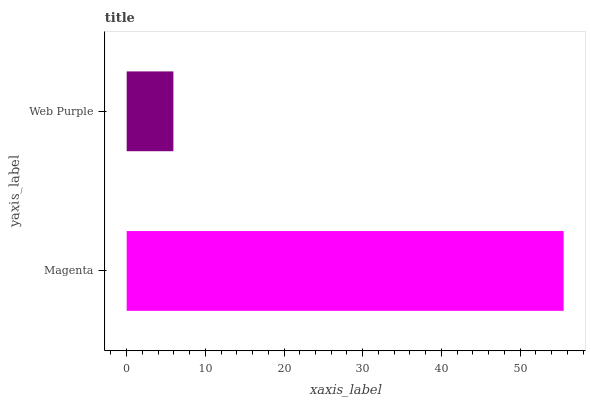Is Web Purple the minimum?
Answer yes or no. Yes. Is Magenta the maximum?
Answer yes or no. Yes. Is Web Purple the maximum?
Answer yes or no. No. Is Magenta greater than Web Purple?
Answer yes or no. Yes. Is Web Purple less than Magenta?
Answer yes or no. Yes. Is Web Purple greater than Magenta?
Answer yes or no. No. Is Magenta less than Web Purple?
Answer yes or no. No. Is Magenta the high median?
Answer yes or no. Yes. Is Web Purple the low median?
Answer yes or no. Yes. Is Web Purple the high median?
Answer yes or no. No. Is Magenta the low median?
Answer yes or no. No. 